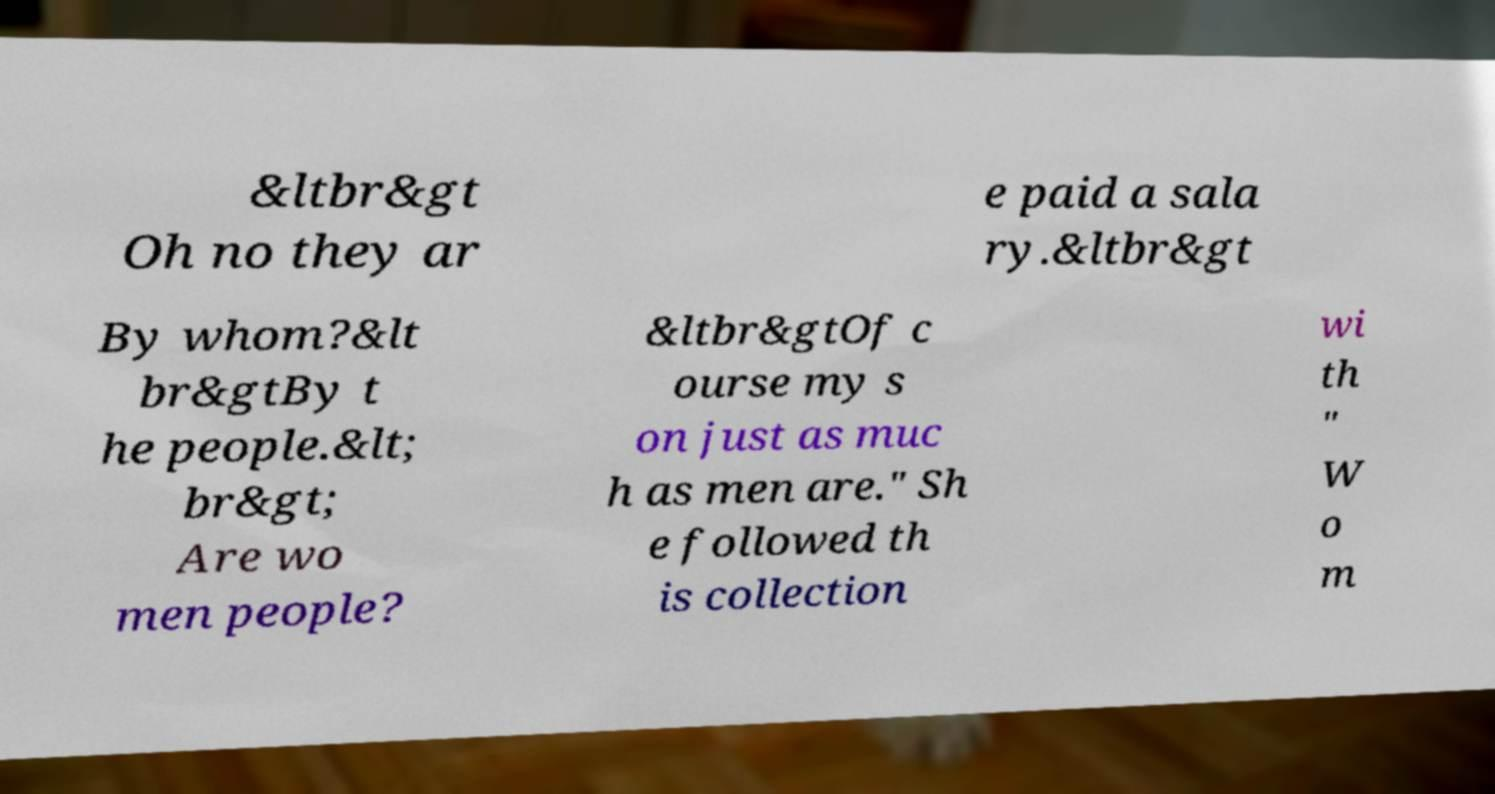There's text embedded in this image that I need extracted. Can you transcribe it verbatim? &ltbr&gt Oh no they ar e paid a sala ry.&ltbr&gt By whom?&lt br&gtBy t he people.&lt; br&gt; Are wo men people? &ltbr&gtOf c ourse my s on just as muc h as men are." Sh e followed th is collection wi th " W o m 